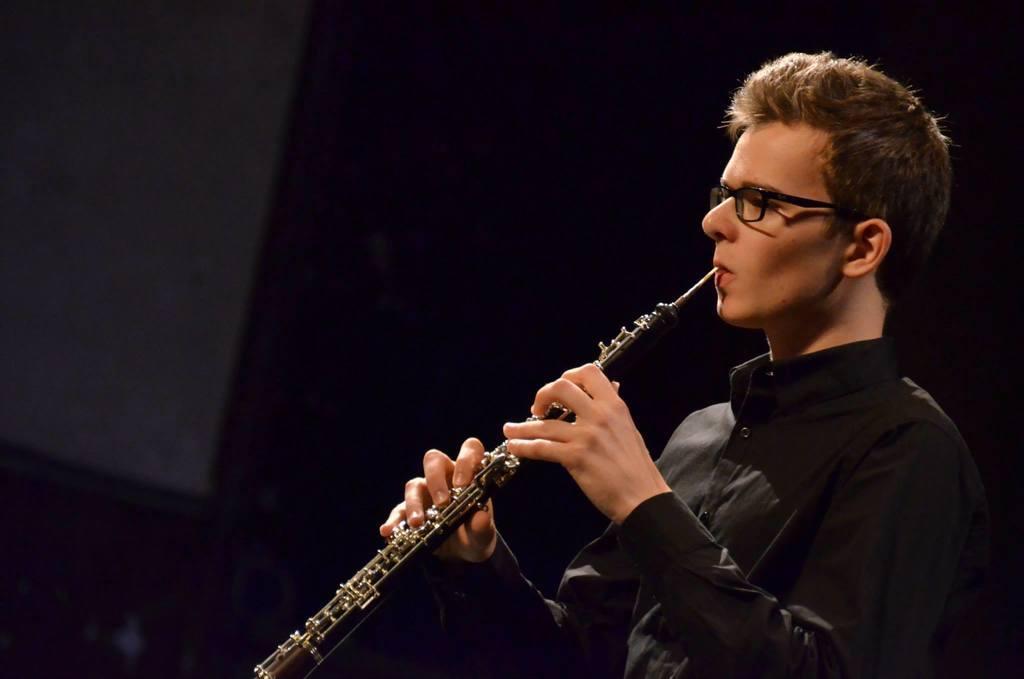How would you summarize this image in a sentence or two? In this image, I can see a person playing clarinet. There is a dark background. 